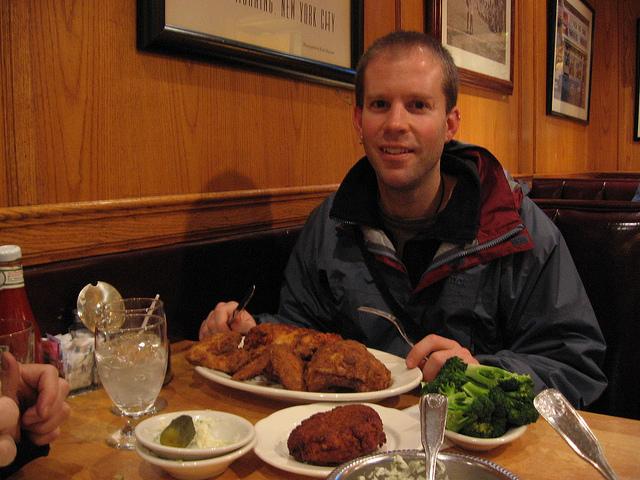How many faces are there with glasses?
Answer briefly. 0. Is this man full?
Quick response, please. No. Is there a tablecloth?
Concise answer only. No. What is being eaten?
Keep it brief. Chicken. What color shirt is the man on the right wearing?
Answer briefly. Black. What is he eating?
Short answer required. Fried chicken. What color is the table?
Keep it brief. Brown. Is the man hungry?
Short answer required. Yes. What is the person cutting?
Keep it brief. Chicken. Are the man's sleeves rolled up?
Be succinct. No. What type of drink is here?
Quick response, please. Water. What do you think they're drinking?
Quick response, please. Water. What is this person eating?
Quick response, please. Chicken. What type of food is set on the table?
Quick response, please. Fried chicken. How many pieces of chicken is on this man's plate?
Short answer required. 4. Is this meal healthy?
Give a very brief answer. No. What is this room?
Write a very short answer. Dining room. What's in the hand?
Answer briefly. Utensils. What is on the man's plate?
Write a very short answer. Chicken. 